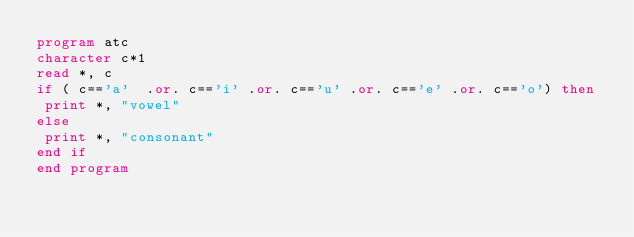<code> <loc_0><loc_0><loc_500><loc_500><_FORTRAN_>program atc
character c*1
read *, c
if ( c=='a'  .or. c=='i' .or. c=='u' .or. c=='e' .or. c=='o') then
 print *, "vowel"
else
 print *, "consonant"
end if
end program</code> 